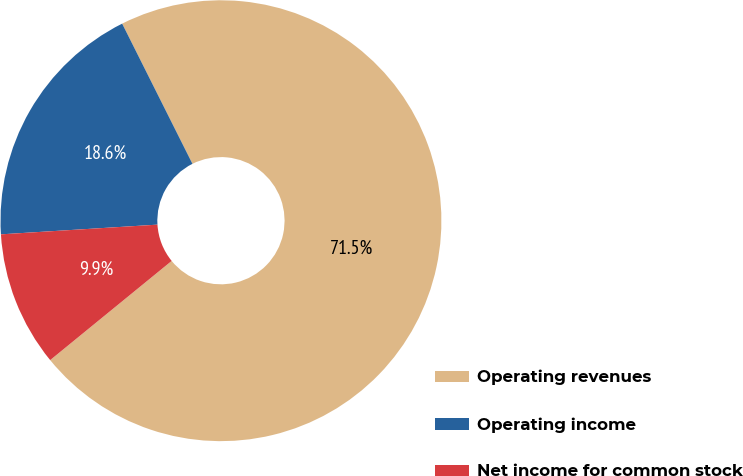<chart> <loc_0><loc_0><loc_500><loc_500><pie_chart><fcel>Operating revenues<fcel>Operating income<fcel>Net income for common stock<nl><fcel>71.5%<fcel>18.59%<fcel>9.91%<nl></chart> 